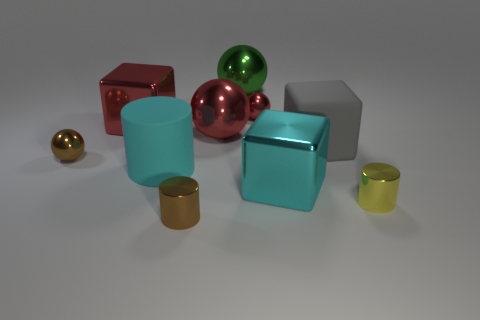Subtract all blocks. How many objects are left? 7 Subtract all green balls. How many balls are left? 3 Subtract all small brown balls. How many balls are left? 3 Subtract 0 green cylinders. How many objects are left? 10 Subtract 1 cylinders. How many cylinders are left? 2 Subtract all red cylinders. Subtract all cyan spheres. How many cylinders are left? 3 Subtract all cyan cylinders. How many yellow blocks are left? 0 Subtract all cyan things. Subtract all green balls. How many objects are left? 7 Add 5 tiny red shiny balls. How many tiny red shiny balls are left? 6 Add 8 big cylinders. How many big cylinders exist? 9 